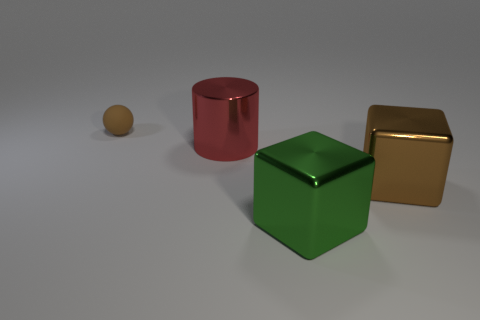Add 3 cyan spheres. How many objects exist? 7 Subtract all cylinders. How many objects are left? 3 Add 1 big brown metallic cubes. How many big brown metallic cubes are left? 2 Add 4 tiny brown balls. How many tiny brown balls exist? 5 Subtract 1 brown cubes. How many objects are left? 3 Subtract all tiny matte objects. Subtract all small matte cylinders. How many objects are left? 3 